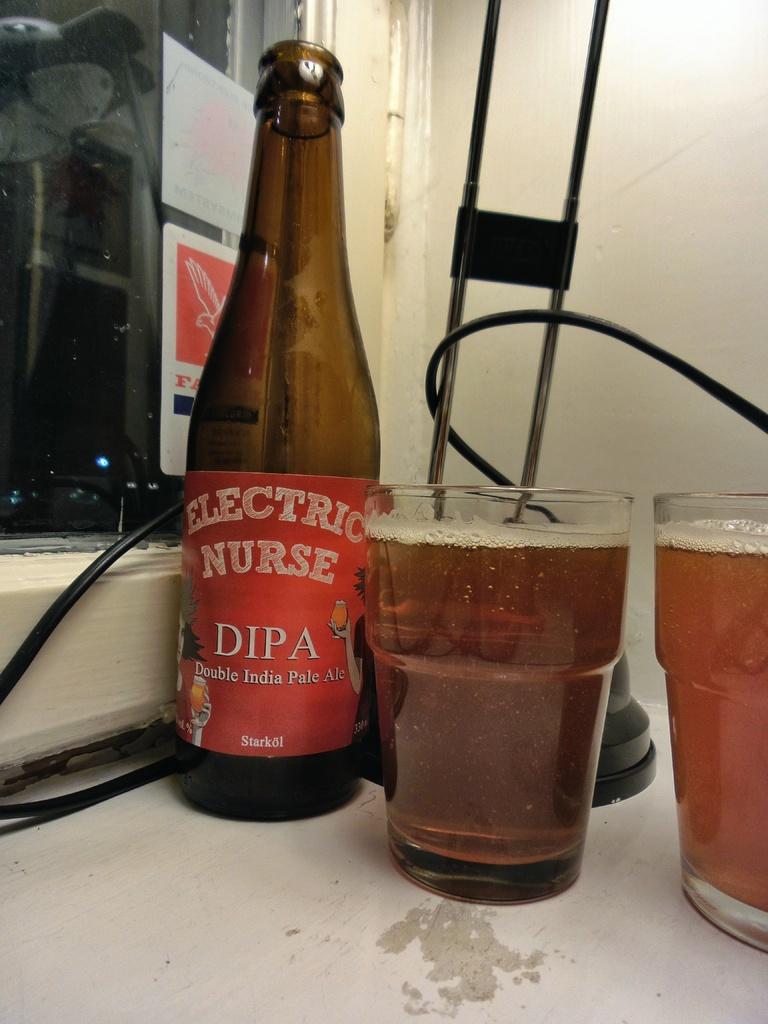What is the name of this pale ale?
Your answer should be compact. Electric nurse. How many glasses can you see?
Your response must be concise. Answering does not require reading text in the image. 